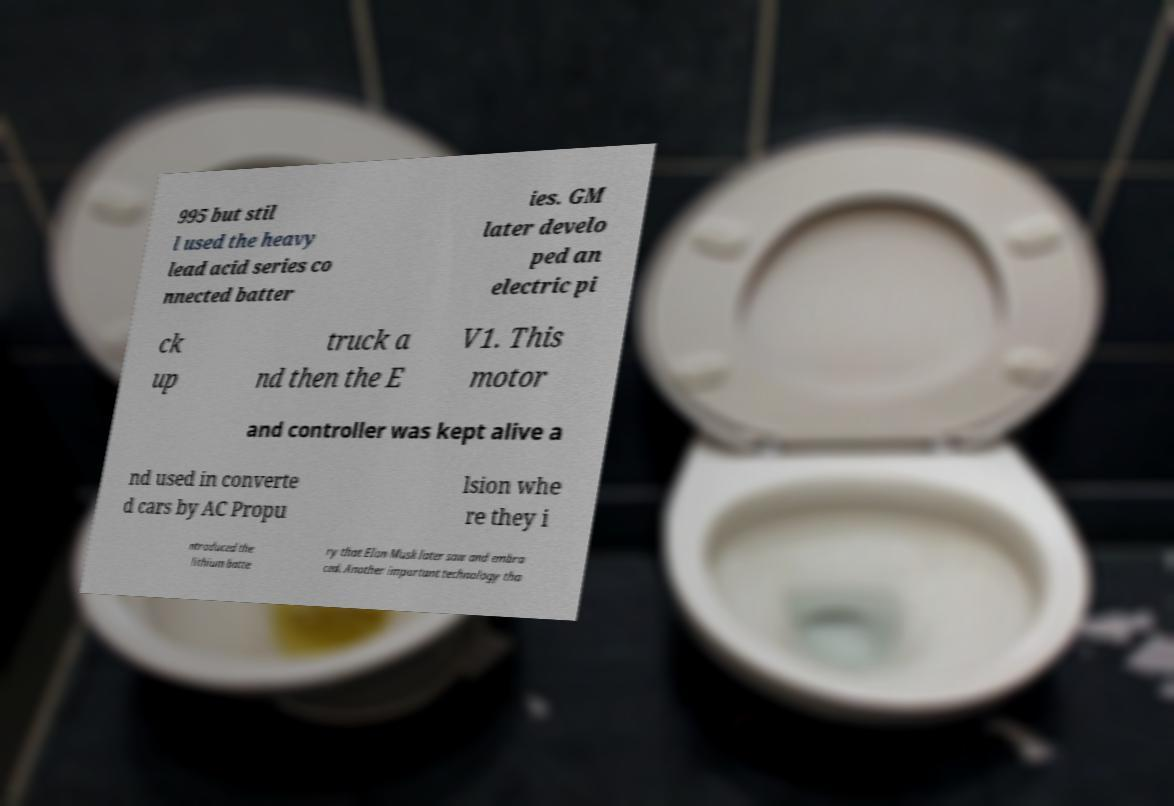What messages or text are displayed in this image? I need them in a readable, typed format. 995 but stil l used the heavy lead acid series co nnected batter ies. GM later develo ped an electric pi ck up truck a nd then the E V1. This motor and controller was kept alive a nd used in converte d cars by AC Propu lsion whe re they i ntroduced the lithium batte ry that Elon Musk later saw and embra ced. Another important technology tha 